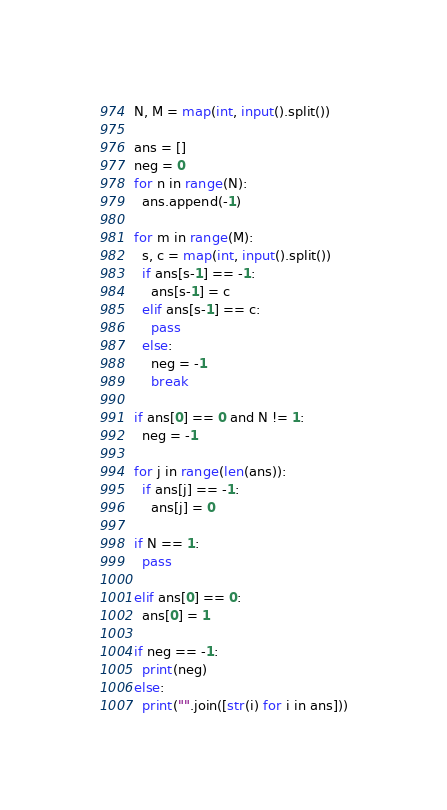Convert code to text. <code><loc_0><loc_0><loc_500><loc_500><_Python_>N, M = map(int, input().split())

ans = []
neg = 0
for n in range(N):
  ans.append(-1)

for m in range(M):
  s, c = map(int, input().split())
  if ans[s-1] == -1:
    ans[s-1] = c
  elif ans[s-1] == c:
    pass
  else:
    neg = -1
    break

if ans[0] == 0 and N != 1:
  neg = -1

for j in range(len(ans)):
  if ans[j] == -1:
    ans[j] = 0

if N == 1:
  pass

elif ans[0] == 0:
  ans[0] = 1

if neg == -1:
  print(neg)
else:
  print("".join([str(i) for i in ans]))</code> 